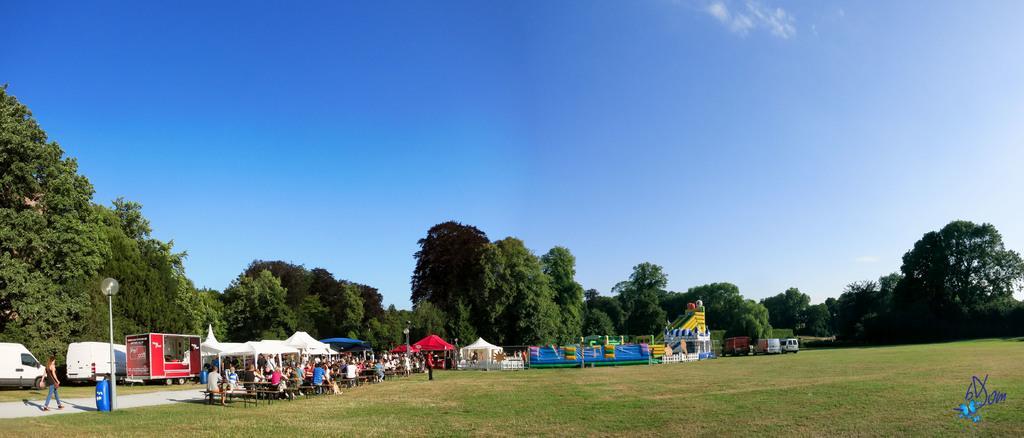Describe this image in one or two sentences. In the image there are trucks and tents in the back with many people sitting in front of it around dining table on the grassland, in the back there are trees and above its sky with clouds. 